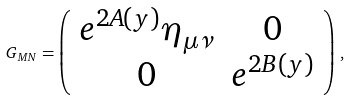<formula> <loc_0><loc_0><loc_500><loc_500>G _ { M N } = \left ( \begin{array} { c c } e ^ { 2 A ( y ) } \eta _ { \mu \nu } & 0 \\ 0 & e ^ { 2 B ( y ) } \end{array} \right ) \, ,</formula> 